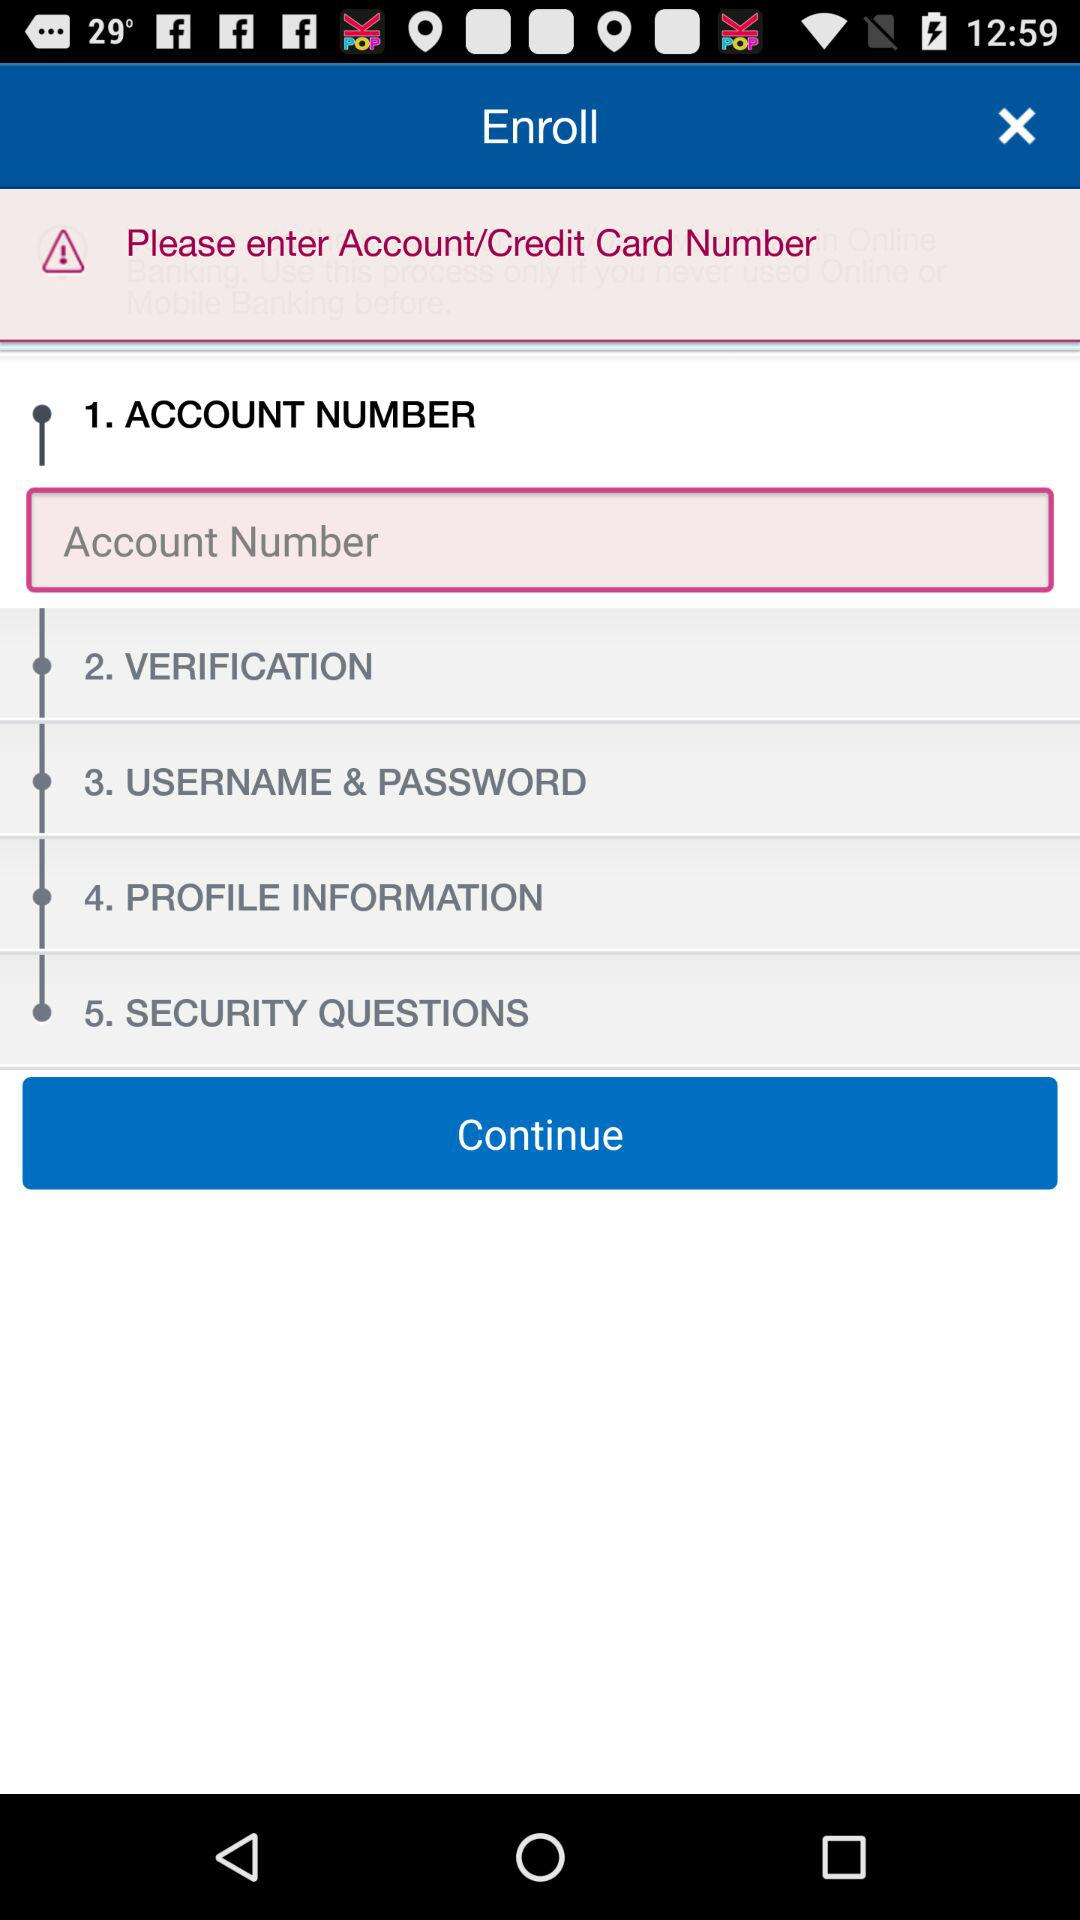On what step is verification? The verification is on step 2. 